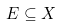<formula> <loc_0><loc_0><loc_500><loc_500>E \subseteq X</formula> 